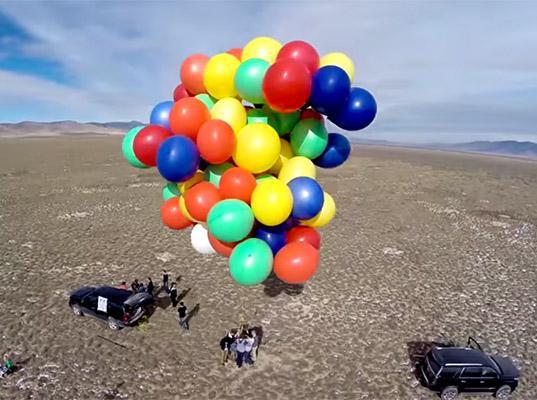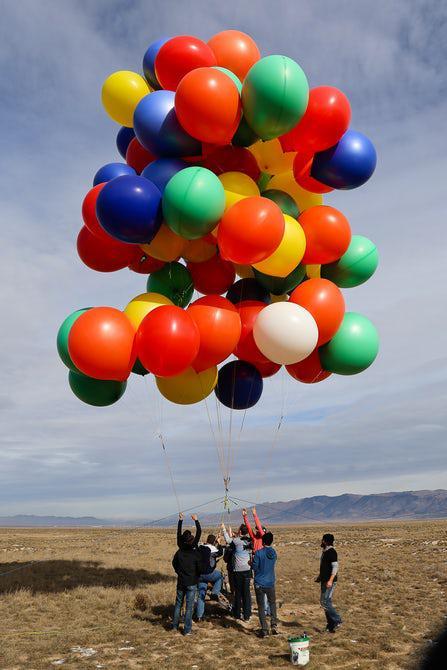The first image is the image on the left, the second image is the image on the right. For the images displayed, is the sentence "Two balloon bunches containing at least a dozen balloons each are in the air in one image." factually correct? Answer yes or no. No. The first image is the image on the left, the second image is the image on the right. Given the left and right images, does the statement "There are three bunches of balloons." hold true? Answer yes or no. No. 